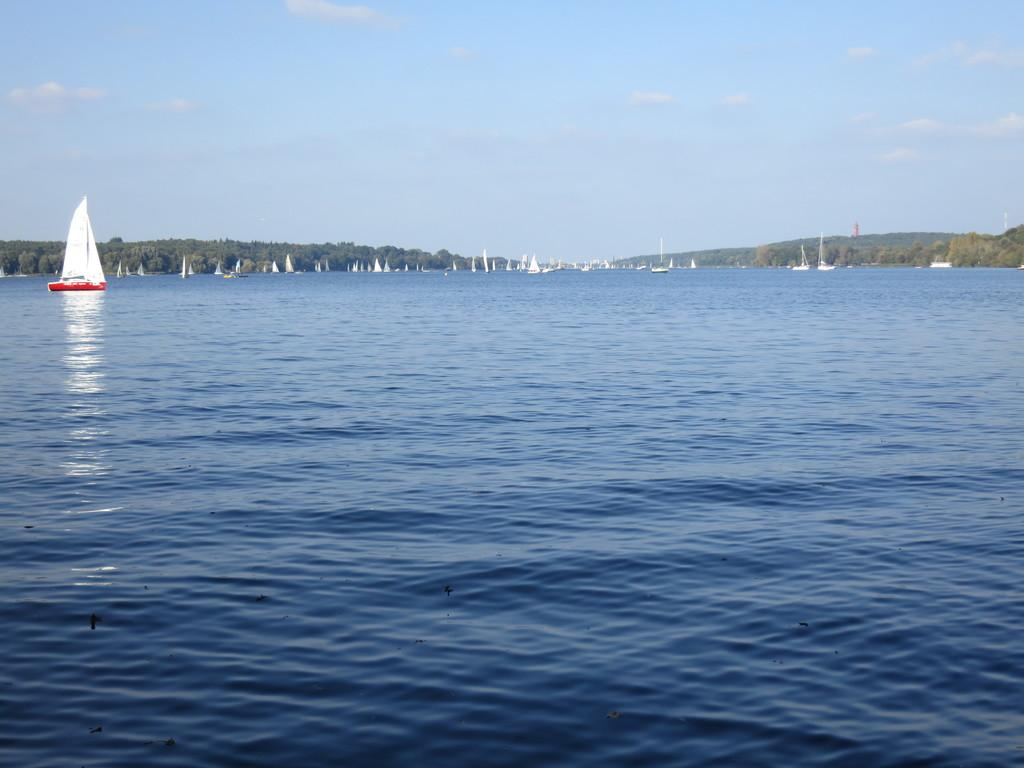What is the main subject of the image? The main subject of the image is a boat. Can you describe the appearance of the boat? The boat is red and white in color. Where is the boat located in the image? The boat is on the water. What can be seen in the background of the image? There are other boats and trees visible in the background, as well as the sky. How does the boat use its tongue to communicate with the other boats in the image? Boats do not have tongues, so they cannot communicate using them. The boat in the image is not shown to be communicating with other boats in any way. 